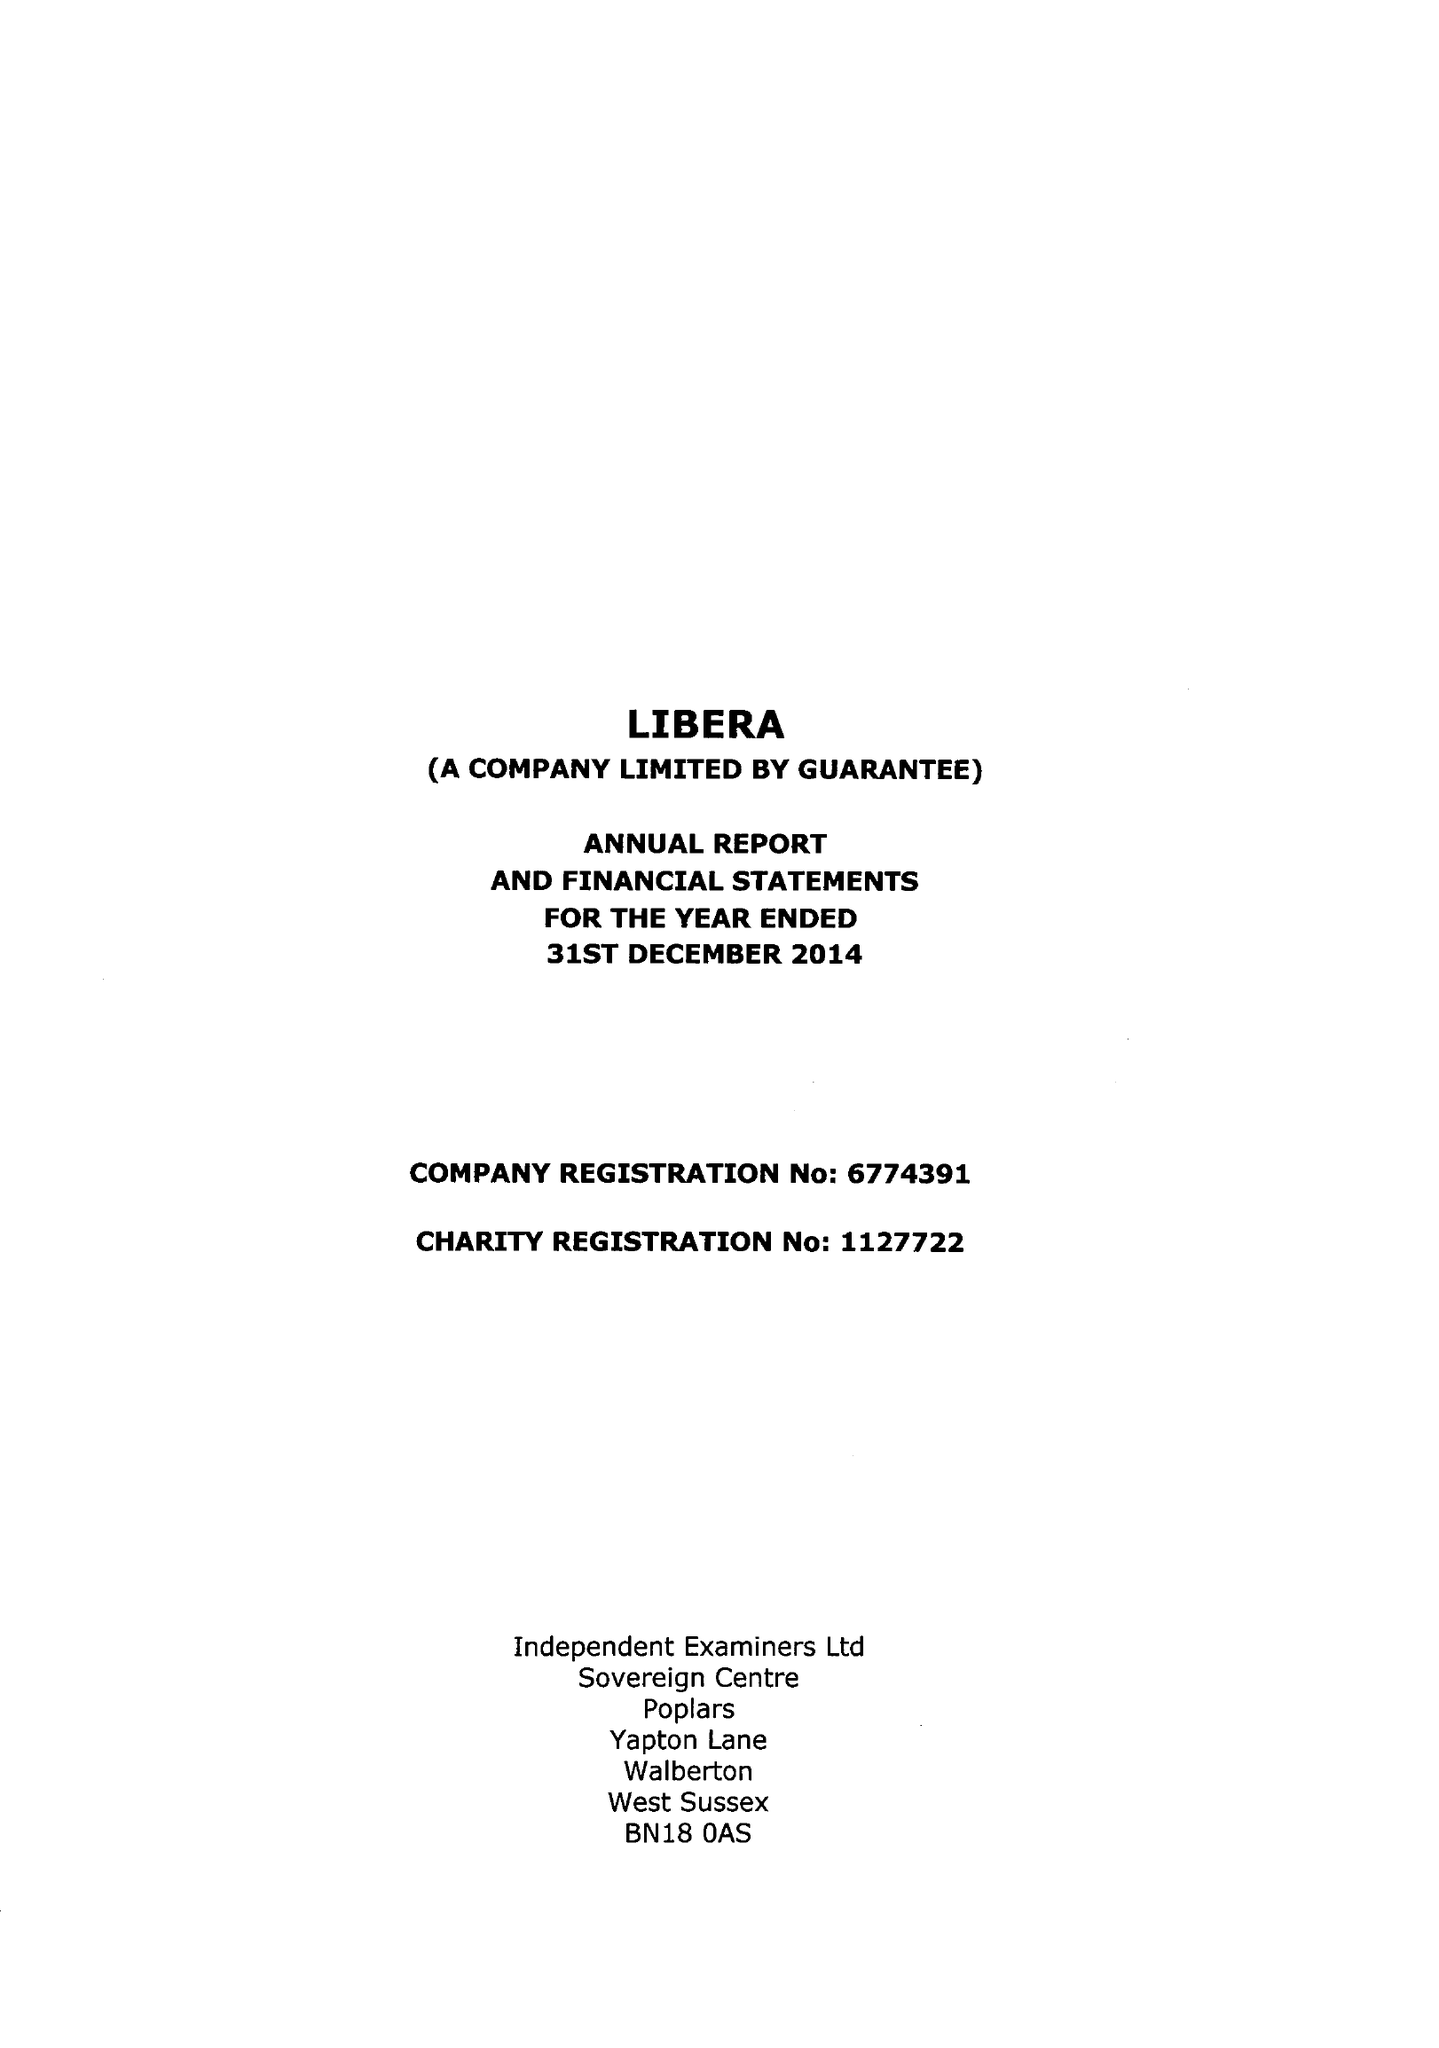What is the value for the charity_name?
Answer the question using a single word or phrase. Libera Ltd. 